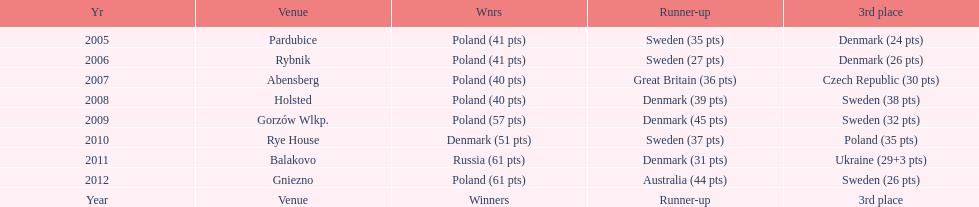Did holland win the 2010 championship? if not who did? Rye House. What did position did holland they rank? 3rd place. 